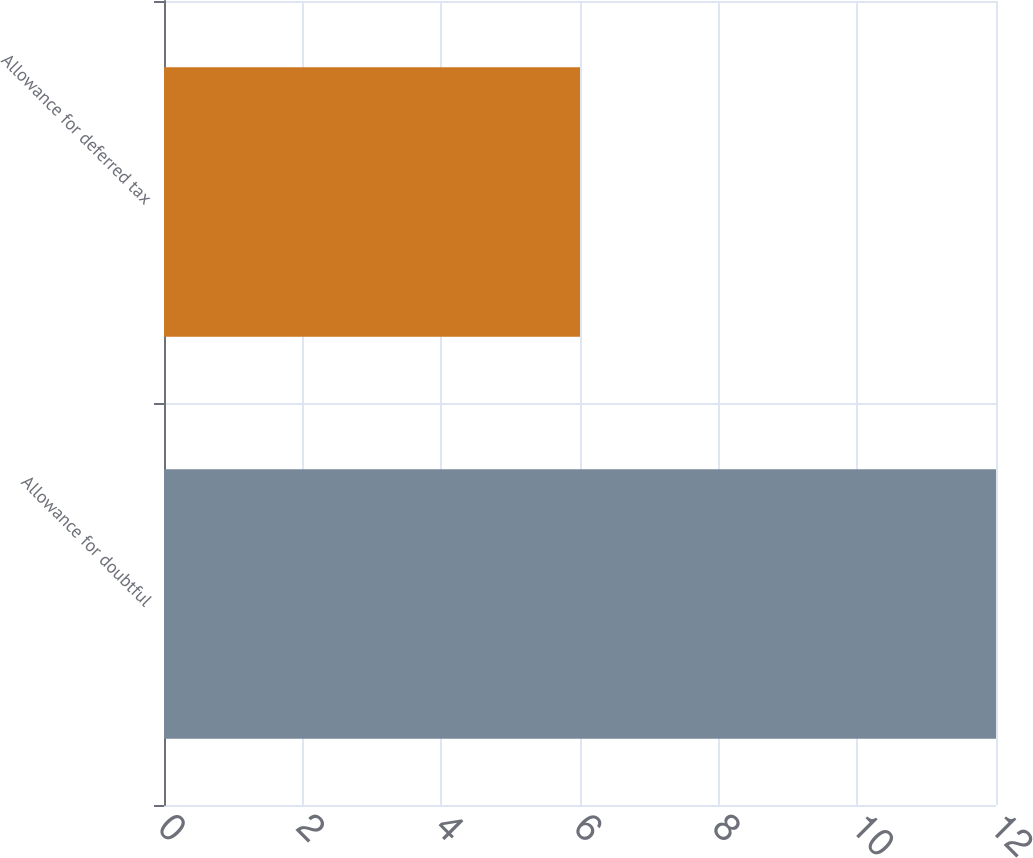Convert chart to OTSL. <chart><loc_0><loc_0><loc_500><loc_500><bar_chart><fcel>Allowance for doubtful<fcel>Allowance for deferred tax<nl><fcel>12<fcel>6<nl></chart> 